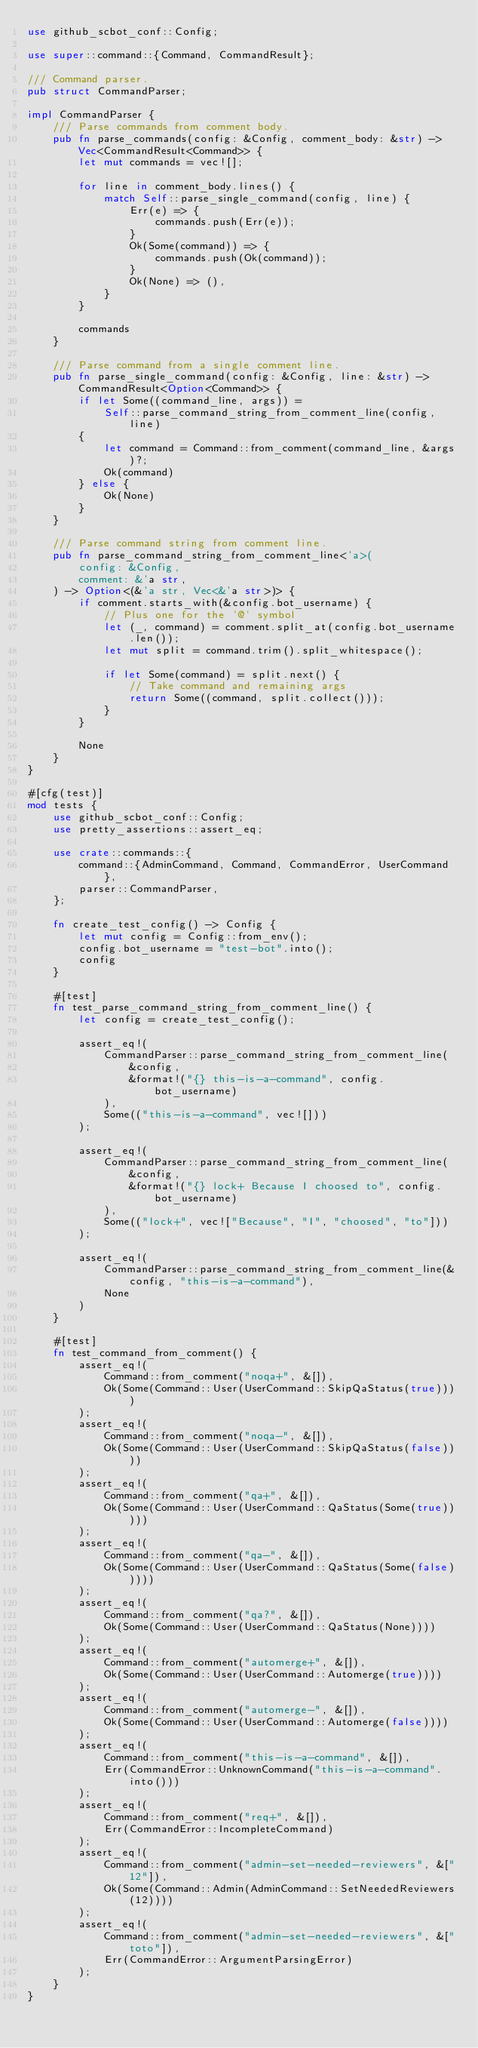<code> <loc_0><loc_0><loc_500><loc_500><_Rust_>use github_scbot_conf::Config;

use super::command::{Command, CommandResult};

/// Command parser.
pub struct CommandParser;

impl CommandParser {
    /// Parse commands from comment body.
    pub fn parse_commands(config: &Config, comment_body: &str) -> Vec<CommandResult<Command>> {
        let mut commands = vec![];

        for line in comment_body.lines() {
            match Self::parse_single_command(config, line) {
                Err(e) => {
                    commands.push(Err(e));
                }
                Ok(Some(command)) => {
                    commands.push(Ok(command));
                }
                Ok(None) => (),
            }
        }

        commands
    }

    /// Parse command from a single comment line.
    pub fn parse_single_command(config: &Config, line: &str) -> CommandResult<Option<Command>> {
        if let Some((command_line, args)) =
            Self::parse_command_string_from_comment_line(config, line)
        {
            let command = Command::from_comment(command_line, &args)?;
            Ok(command)
        } else {
            Ok(None)
        }
    }

    /// Parse command string from comment line.
    pub fn parse_command_string_from_comment_line<'a>(
        config: &Config,
        comment: &'a str,
    ) -> Option<(&'a str, Vec<&'a str>)> {
        if comment.starts_with(&config.bot_username) {
            // Plus one for the '@' symbol
            let (_, command) = comment.split_at(config.bot_username.len());
            let mut split = command.trim().split_whitespace();

            if let Some(command) = split.next() {
                // Take command and remaining args
                return Some((command, split.collect()));
            }
        }

        None
    }
}

#[cfg(test)]
mod tests {
    use github_scbot_conf::Config;
    use pretty_assertions::assert_eq;

    use crate::commands::{
        command::{AdminCommand, Command, CommandError, UserCommand},
        parser::CommandParser,
    };

    fn create_test_config() -> Config {
        let mut config = Config::from_env();
        config.bot_username = "test-bot".into();
        config
    }

    #[test]
    fn test_parse_command_string_from_comment_line() {
        let config = create_test_config();

        assert_eq!(
            CommandParser::parse_command_string_from_comment_line(
                &config,
                &format!("{} this-is-a-command", config.bot_username)
            ),
            Some(("this-is-a-command", vec![]))
        );

        assert_eq!(
            CommandParser::parse_command_string_from_comment_line(
                &config,
                &format!("{} lock+ Because I choosed to", config.bot_username)
            ),
            Some(("lock+", vec!["Because", "I", "choosed", "to"]))
        );

        assert_eq!(
            CommandParser::parse_command_string_from_comment_line(&config, "this-is-a-command"),
            None
        )
    }

    #[test]
    fn test_command_from_comment() {
        assert_eq!(
            Command::from_comment("noqa+", &[]),
            Ok(Some(Command::User(UserCommand::SkipQaStatus(true))))
        );
        assert_eq!(
            Command::from_comment("noqa-", &[]),
            Ok(Some(Command::User(UserCommand::SkipQaStatus(false))))
        );
        assert_eq!(
            Command::from_comment("qa+", &[]),
            Ok(Some(Command::User(UserCommand::QaStatus(Some(true)))))
        );
        assert_eq!(
            Command::from_comment("qa-", &[]),
            Ok(Some(Command::User(UserCommand::QaStatus(Some(false)))))
        );
        assert_eq!(
            Command::from_comment("qa?", &[]),
            Ok(Some(Command::User(UserCommand::QaStatus(None))))
        );
        assert_eq!(
            Command::from_comment("automerge+", &[]),
            Ok(Some(Command::User(UserCommand::Automerge(true))))
        );
        assert_eq!(
            Command::from_comment("automerge-", &[]),
            Ok(Some(Command::User(UserCommand::Automerge(false))))
        );
        assert_eq!(
            Command::from_comment("this-is-a-command", &[]),
            Err(CommandError::UnknownCommand("this-is-a-command".into()))
        );
        assert_eq!(
            Command::from_comment("req+", &[]),
            Err(CommandError::IncompleteCommand)
        );
        assert_eq!(
            Command::from_comment("admin-set-needed-reviewers", &["12"]),
            Ok(Some(Command::Admin(AdminCommand::SetNeededReviewers(12))))
        );
        assert_eq!(
            Command::from_comment("admin-set-needed-reviewers", &["toto"]),
            Err(CommandError::ArgumentParsingError)
        );
    }
}
</code> 